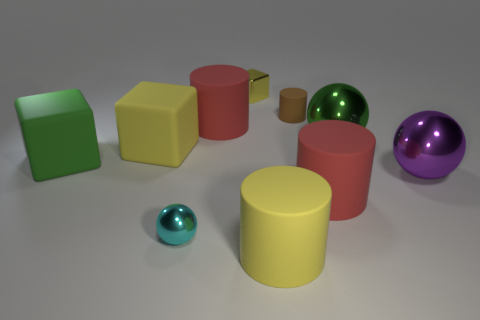What shape is the small metallic thing that is behind the red rubber object on the right side of the small brown object?
Provide a short and direct response. Cube. Is there any other thing of the same color as the tiny block?
Offer a very short reply. Yes. Is there a small metal ball behind the large yellow object behind the red object on the right side of the small brown thing?
Offer a very short reply. No. Do the small thing behind the brown thing and the big block to the right of the green matte object have the same color?
Your answer should be very brief. Yes. There is a cyan object that is the same size as the metallic cube; what is its material?
Provide a short and direct response. Metal. There is a metal sphere left of the block that is behind the tiny rubber cylinder that is to the right of the small yellow shiny thing; how big is it?
Provide a succinct answer. Small. How many other things are the same material as the big green sphere?
Make the answer very short. 3. How big is the yellow matte object to the left of the cyan metallic ball?
Offer a very short reply. Large. What number of objects are to the left of the tiny yellow shiny object and behind the large purple thing?
Your response must be concise. 3. The large red cylinder that is right of the large red matte cylinder that is left of the yellow rubber cylinder is made of what material?
Your response must be concise. Rubber. 